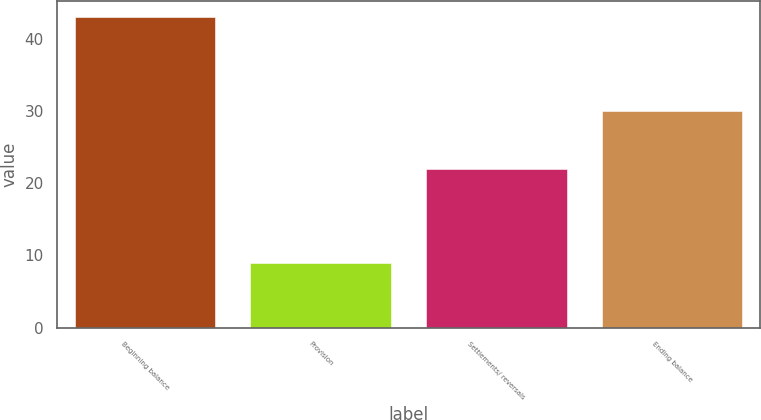Convert chart to OTSL. <chart><loc_0><loc_0><loc_500><loc_500><bar_chart><fcel>Beginning balance<fcel>Provision<fcel>Settlements/ reversals<fcel>Ending balance<nl><fcel>43<fcel>9<fcel>22<fcel>30<nl></chart> 